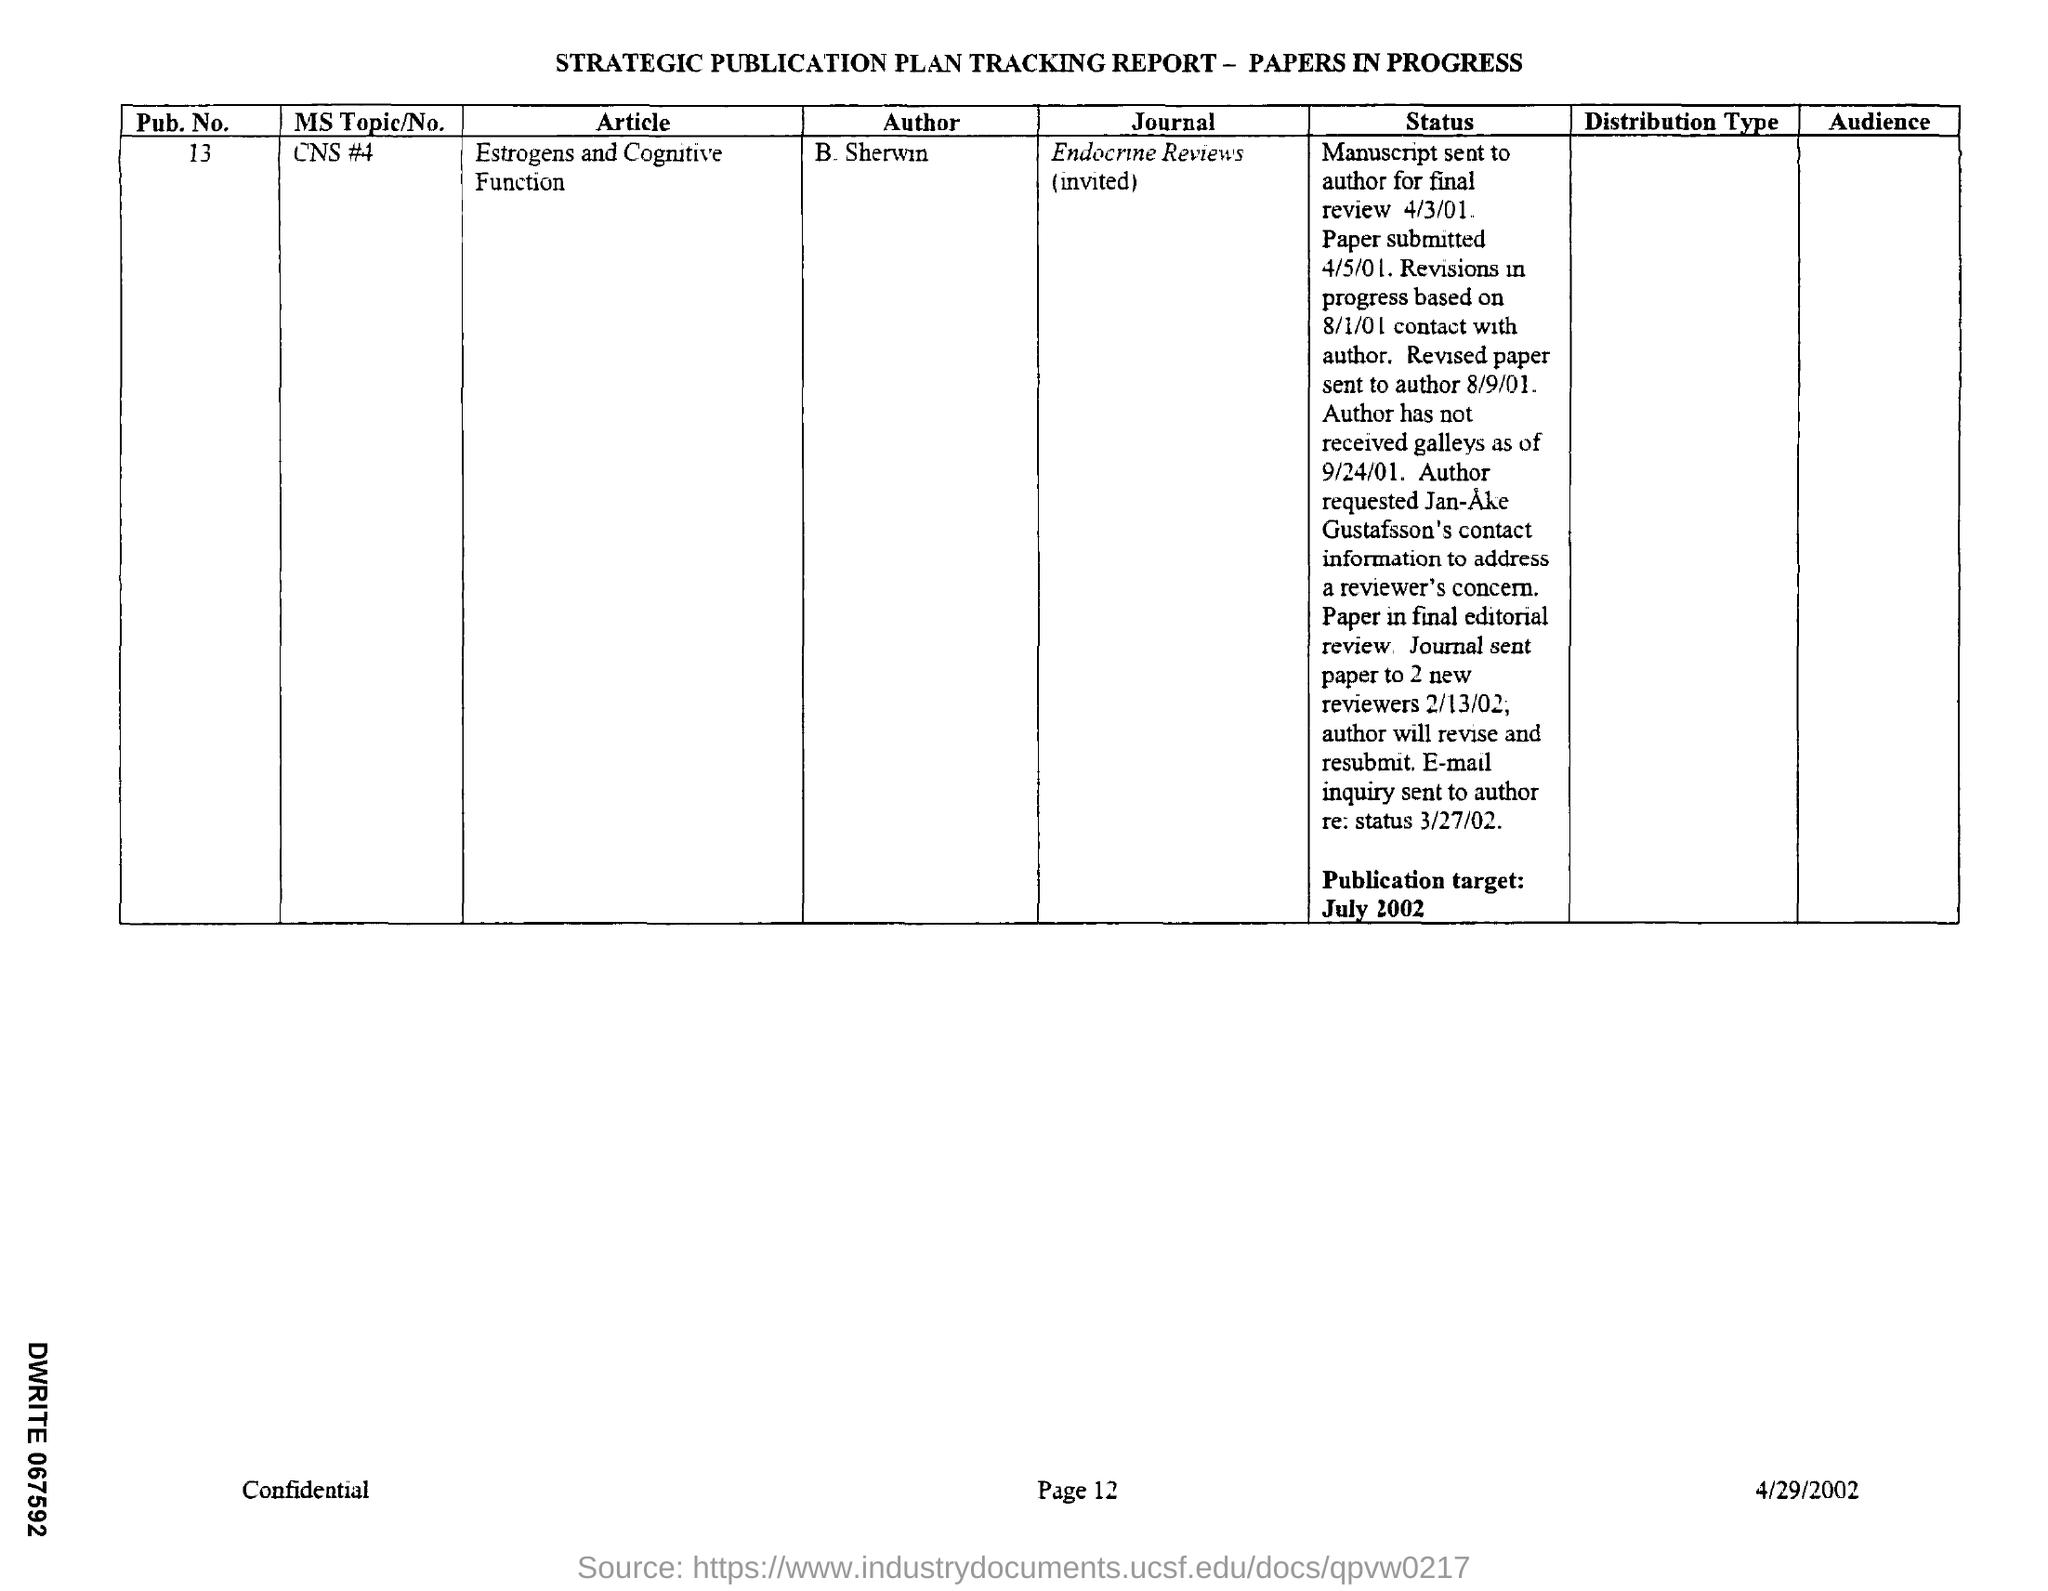What is the name of the article mentioned in the given report ?
Make the answer very short. Estrogens and cognitive function. What is the pub.no. mentioned in the report ?
Keep it short and to the point. 13. What is the ms topic/no mentioned in the given report ?
Keep it short and to the point. CNS #4. 